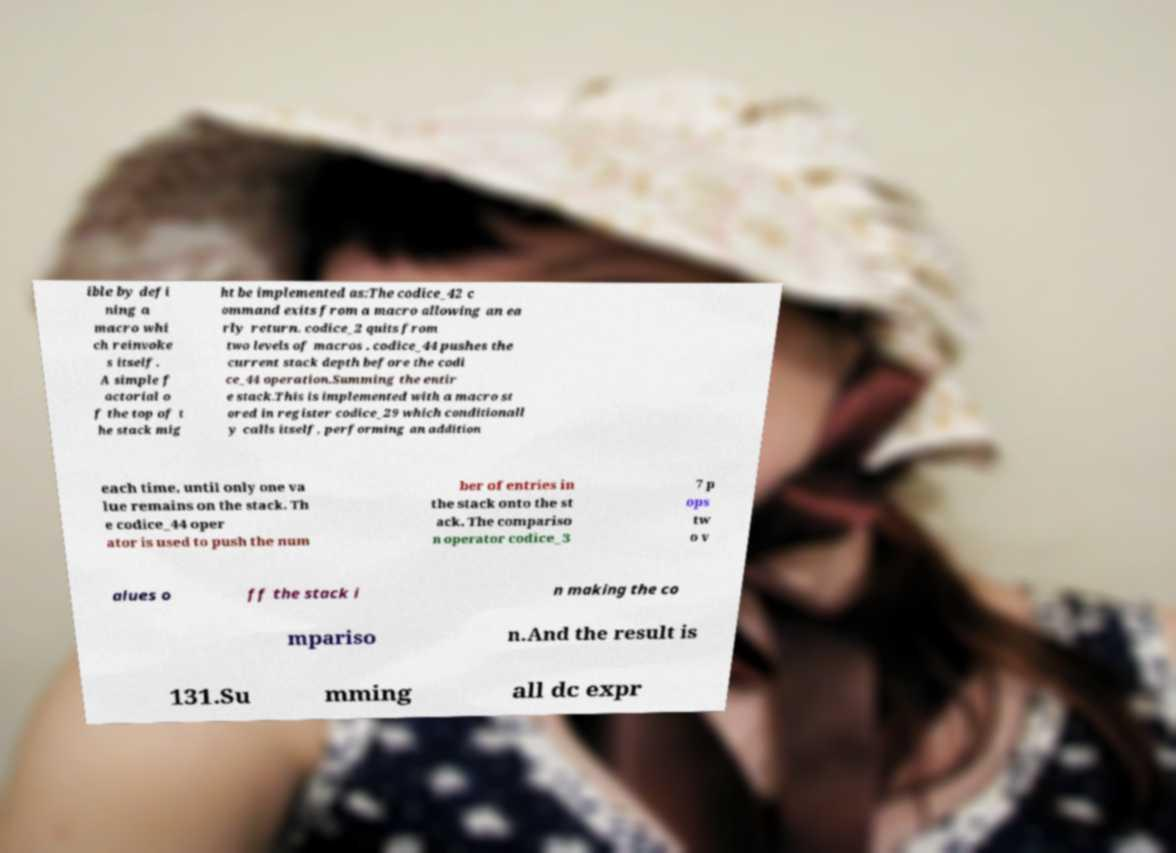Please identify and transcribe the text found in this image. ible by defi ning a macro whi ch reinvoke s itself. A simple f actorial o f the top of t he stack mig ht be implemented as:The codice_42 c ommand exits from a macro allowing an ea rly return. codice_2 quits from two levels of macros . codice_44 pushes the current stack depth before the codi ce_44 operation.Summing the entir e stack.This is implemented with a macro st ored in register codice_29 which conditionall y calls itself, performing an addition each time, until only one va lue remains on the stack. Th e codice_44 oper ator is used to push the num ber of entries in the stack onto the st ack. The compariso n operator codice_3 7 p ops tw o v alues o ff the stack i n making the co mpariso n.And the result is 131.Su mming all dc expr 